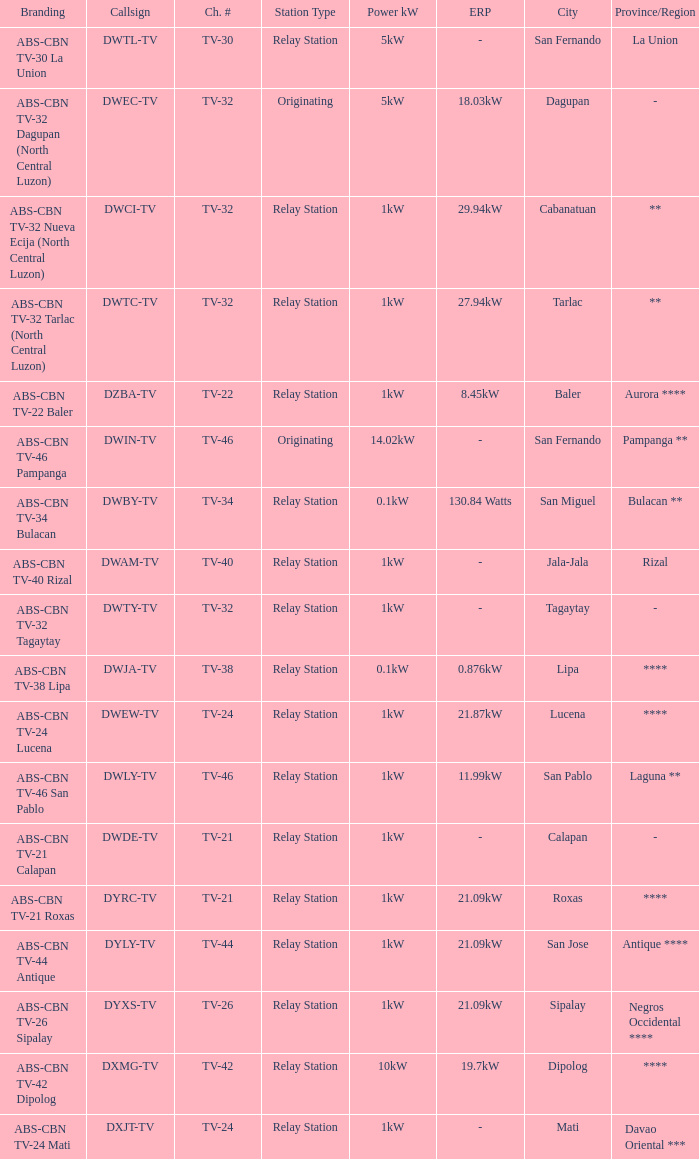In the context of branding, what classification does abs-cbn tv-32 tagaytay fall under as a station type? Relay Station. 